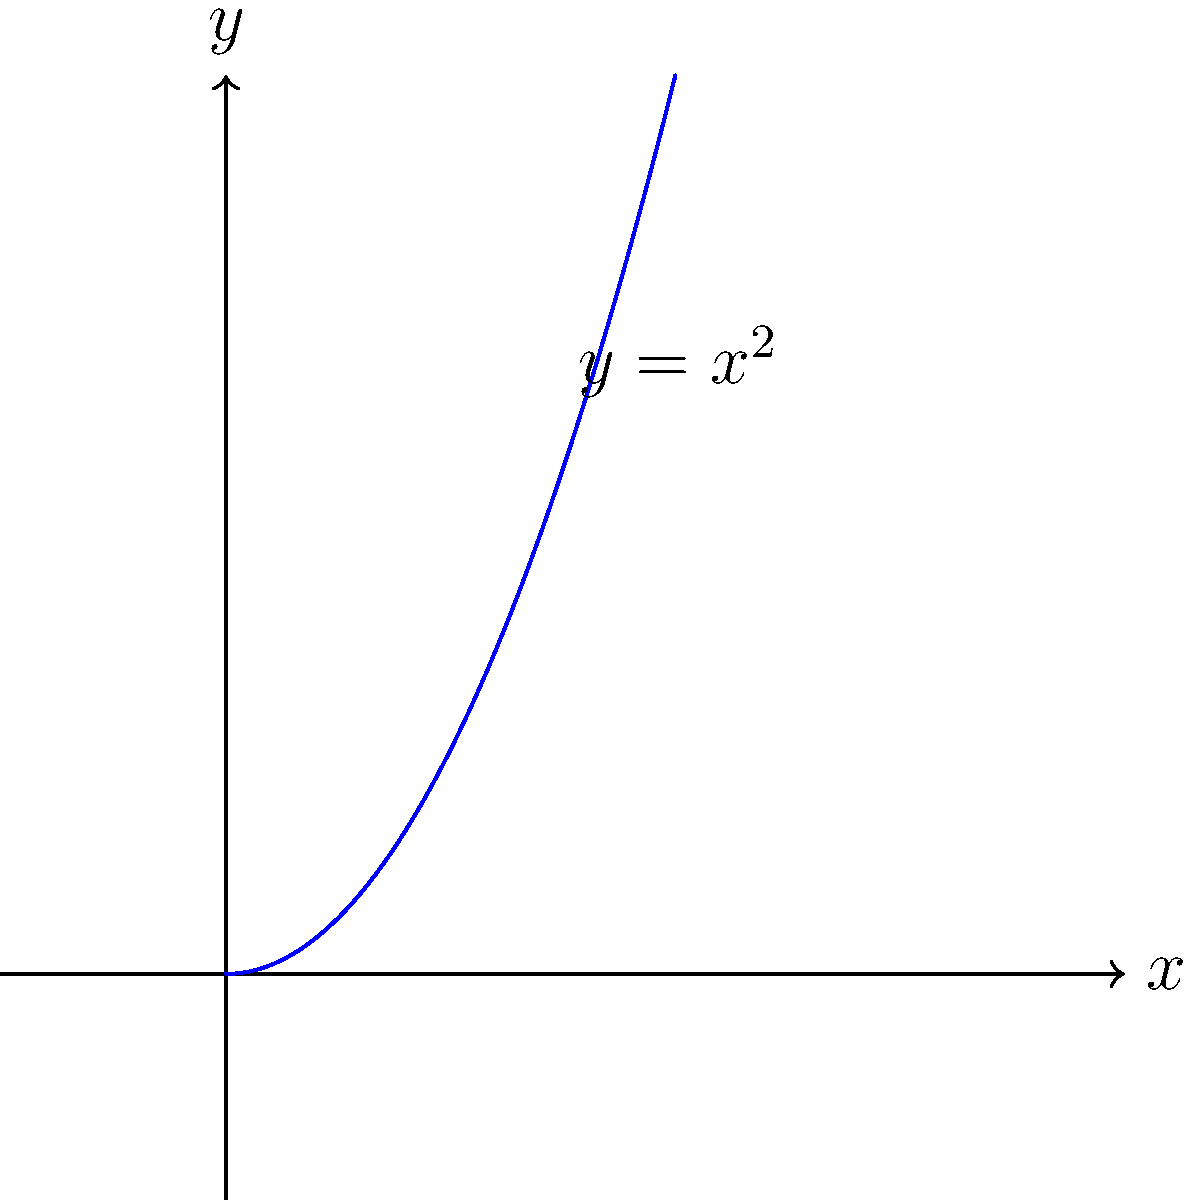Identify the equation represented by the hand-drawn curve in the diagram. Which fundamental physics concept does this equation relate to? To identify the equation and its relation to physics, let's follow these steps:

1. Observe the shape: The curve is a parabola opening upwards.

2. Identify the equation: The general form of a parabola is $y = ax^2 + bx + c$. In this case, the parabola passes through the origin (0,0) and is symmetrical about the y-axis. This suggests the equation is in its simplest form: $y = x^2$.

3. Physics concept: This equation relates to several fundamental physics concepts, but most prominently to:

   a) Projectile motion: In a uniform gravitational field (neglecting air resistance), the vertical position of a projectile follows a parabolic path described by $y = -\frac{1}{2}gt^2 + v_0t + y_0$, where $g$ is gravitational acceleration, $t$ is time, $v_0$ is initial velocity, and $y_0$ is initial height.

   b) Potential energy in a simple harmonic oscillator: The potential energy of a spring system is given by $U = \frac{1}{2}kx^2$, where $k$ is the spring constant and $x$ is the displacement from equilibrium.

4. Historical context: The study of parabolas and their applications in physics dates back to ancient Greek mathematicians like Apollonius of Perga (c. 262-190 BCE). However, it was Galileo Galilei (1564-1642) who first correctly described the parabolic trajectory of projectiles, laying the groundwork for classical mechanics.

Given the persona of an amateur historian with a passion for physics, the most relevant and fundamental physics concept related to this equation is projectile motion, as it represents a cornerstone in the development of classical mechanics.
Answer: $y = x^2$; Projectile motion 